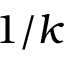Convert formula to latex. <formula><loc_0><loc_0><loc_500><loc_500>1 / k</formula> 